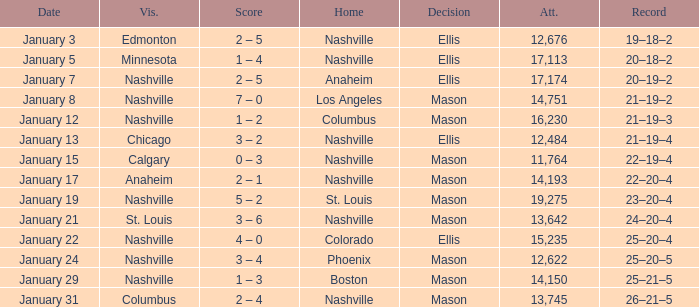On January 29, who had the decision of Mason? Nashville. 